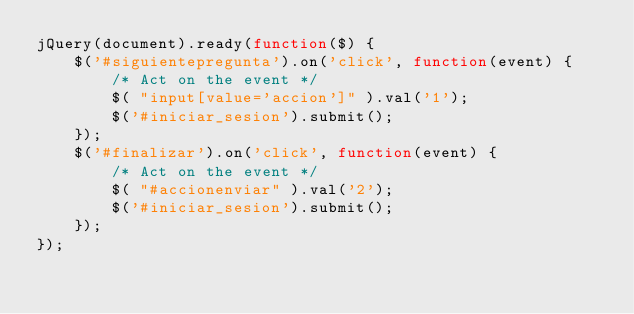Convert code to text. <code><loc_0><loc_0><loc_500><loc_500><_JavaScript_>jQuery(document).ready(function($) {
	$('#siguientepregunta').on('click', function(event) {
		/* Act on the event */
		$( "input[value='accion']" ).val('1');
		$('#iniciar_sesion').submit();
	});
	$('#finalizar').on('click', function(event) {
		/* Act on the event */
		$( "#accionenviar" ).val('2');
		$('#iniciar_sesion').submit();
	});
});</code> 